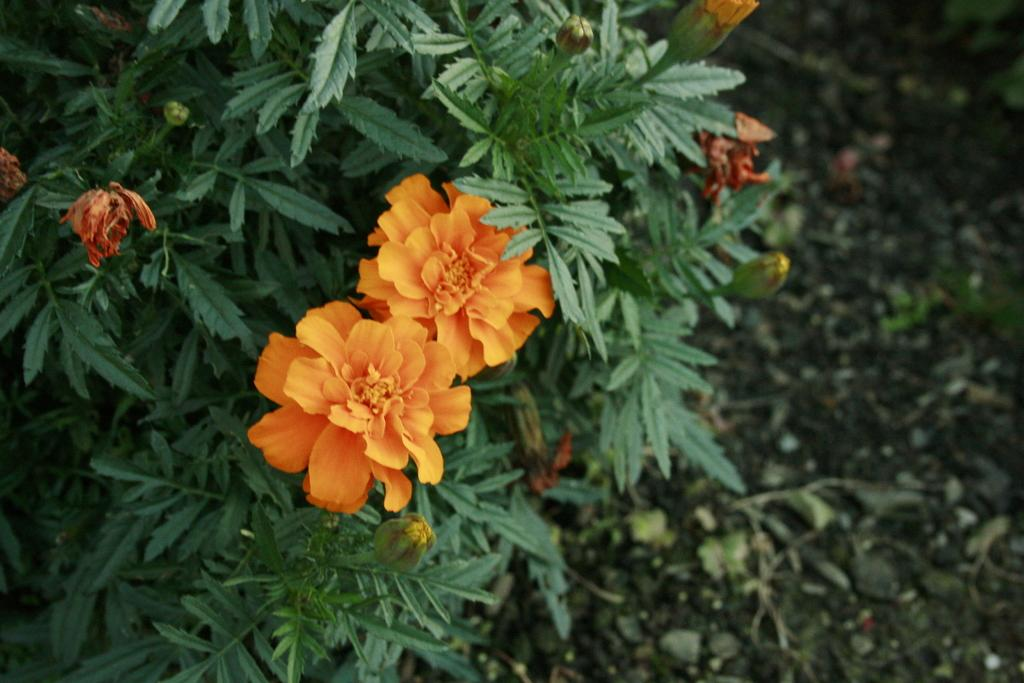What is the main subject of the image? There is a plant in the center of the image. What can be observed about the plant's appearance? The plant has flowers and buds, and the flowers are orange in color. What type of surface is visible at the bottom of the image? There is ground visible at the bottom of the image. What type of sign can be seen in the image? There is no sign present in the image; it features a plant with flowers and buds. What day of the week is depicted in the image? The image does not depict a specific day of the week; it is a still image of a plant. 